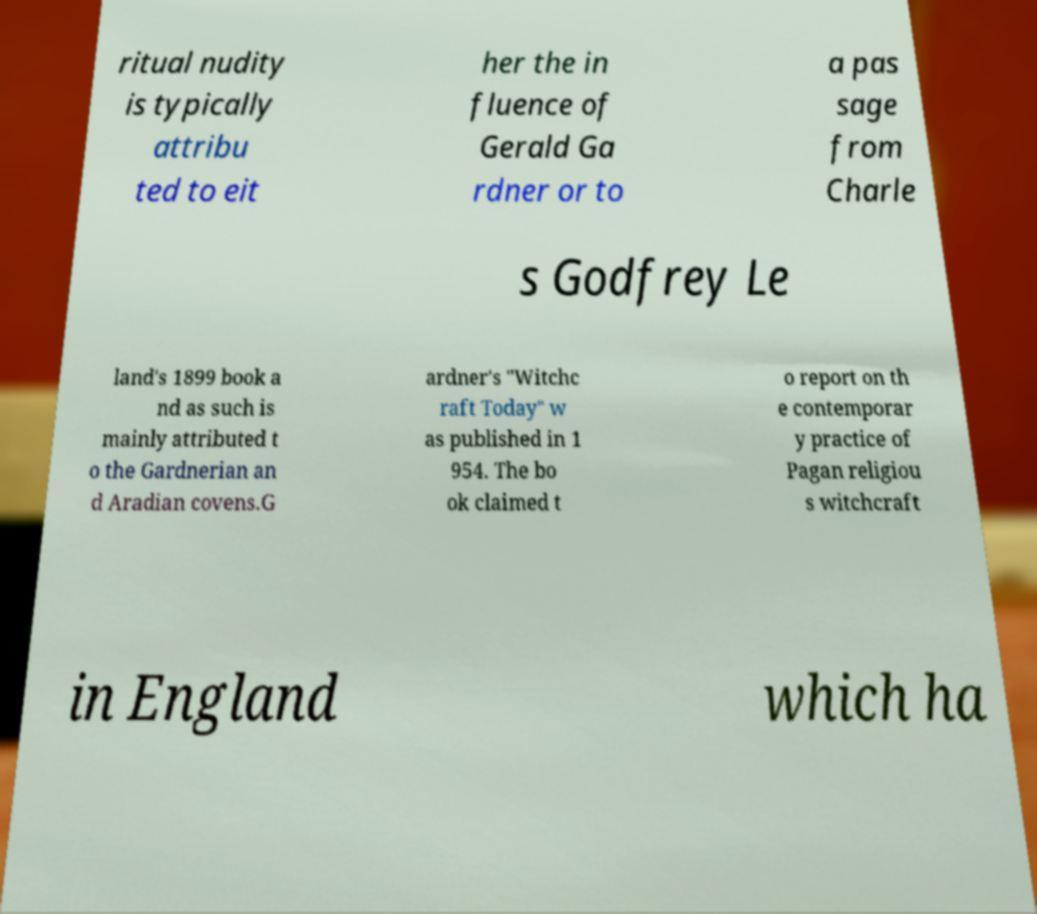For documentation purposes, I need the text within this image transcribed. Could you provide that? ritual nudity is typically attribu ted to eit her the in fluence of Gerald Ga rdner or to a pas sage from Charle s Godfrey Le land's 1899 book a nd as such is mainly attributed t o the Gardnerian an d Aradian covens.G ardner's "Witchc raft Today" w as published in 1 954. The bo ok claimed t o report on th e contemporar y practice of Pagan religiou s witchcraft in England which ha 